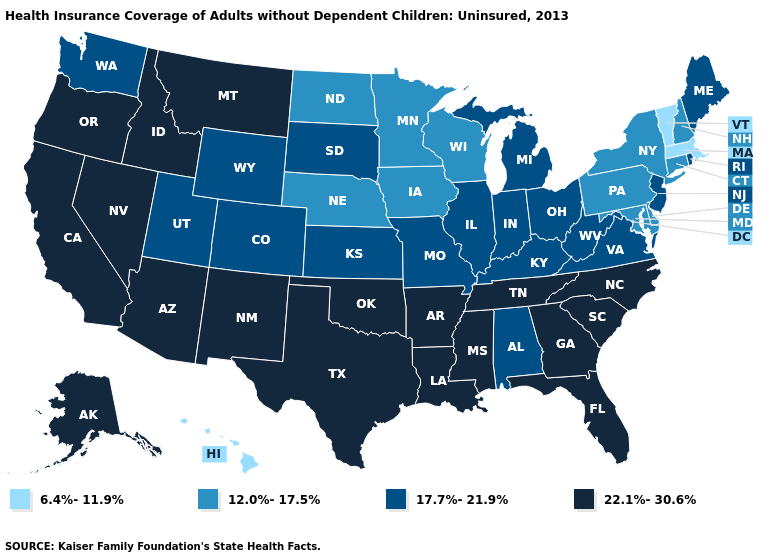What is the value of Pennsylvania?
Keep it brief. 12.0%-17.5%. What is the value of California?
Concise answer only. 22.1%-30.6%. Is the legend a continuous bar?
Keep it brief. No. Among the states that border Nevada , which have the lowest value?
Write a very short answer. Utah. Does the first symbol in the legend represent the smallest category?
Give a very brief answer. Yes. Does Oklahoma have the same value as North Dakota?
Write a very short answer. No. What is the highest value in states that border Wisconsin?
Answer briefly. 17.7%-21.9%. Does Washington have the same value as Louisiana?
Be succinct. No. Does New Mexico have the highest value in the West?
Keep it brief. Yes. Which states have the lowest value in the MidWest?
Quick response, please. Iowa, Minnesota, Nebraska, North Dakota, Wisconsin. What is the value of Wyoming?
Answer briefly. 17.7%-21.9%. What is the value of Rhode Island?
Quick response, please. 17.7%-21.9%. What is the lowest value in the West?
Answer briefly. 6.4%-11.9%. Does the first symbol in the legend represent the smallest category?
Write a very short answer. Yes. What is the value of Mississippi?
Answer briefly. 22.1%-30.6%. 